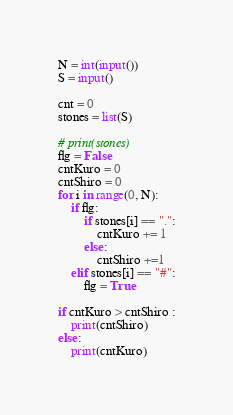Convert code to text. <code><loc_0><loc_0><loc_500><loc_500><_Python_>N = int(input())
S = input()

cnt = 0
stones = list(S)

# print(stones)
flg = False
cntKuro = 0
cntShiro = 0
for i in range(0, N):
    if flg:
        if stones[i] == ".":
            cntKuro += 1
        else:
            cntShiro +=1
    elif stones[i] == "#":
        flg = True

if cntKuro > cntShiro :
    print(cntShiro)
else:
    print(cntKuro)</code> 